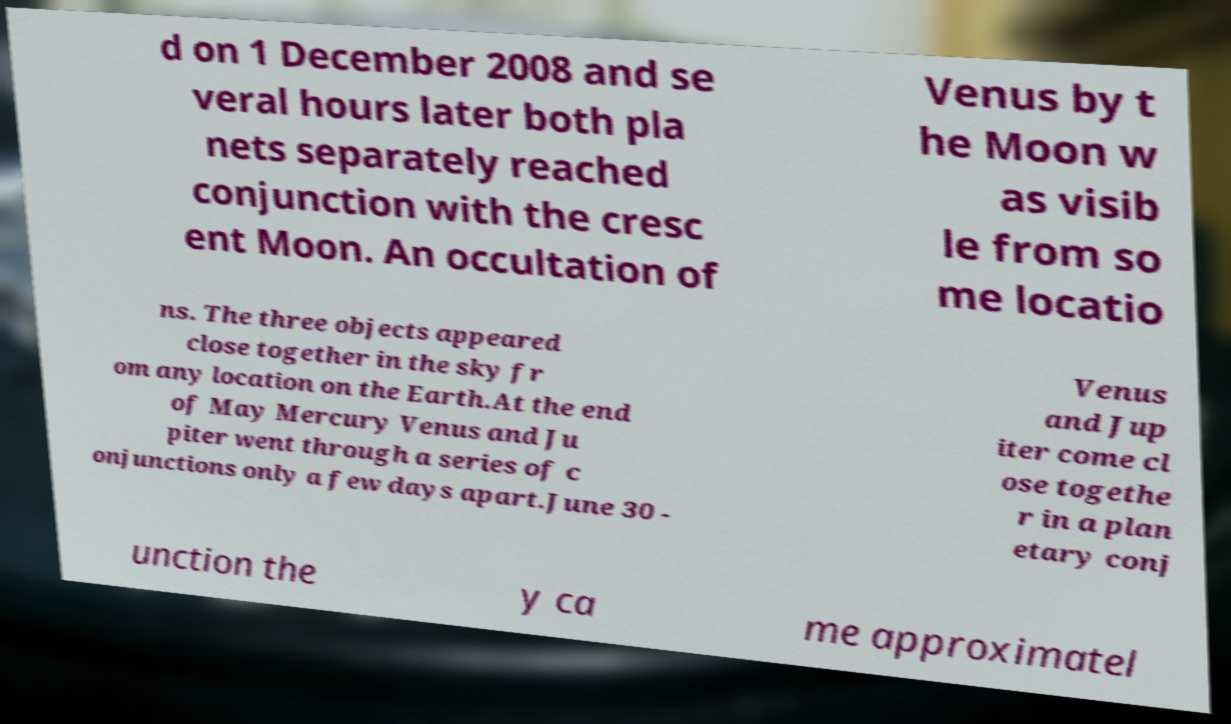Can you accurately transcribe the text from the provided image for me? d on 1 December 2008 and se veral hours later both pla nets separately reached conjunction with the cresc ent Moon. An occultation of Venus by t he Moon w as visib le from so me locatio ns. The three objects appeared close together in the sky fr om any location on the Earth.At the end of May Mercury Venus and Ju piter went through a series of c onjunctions only a few days apart.June 30 - Venus and Jup iter come cl ose togethe r in a plan etary conj unction the y ca me approximatel 